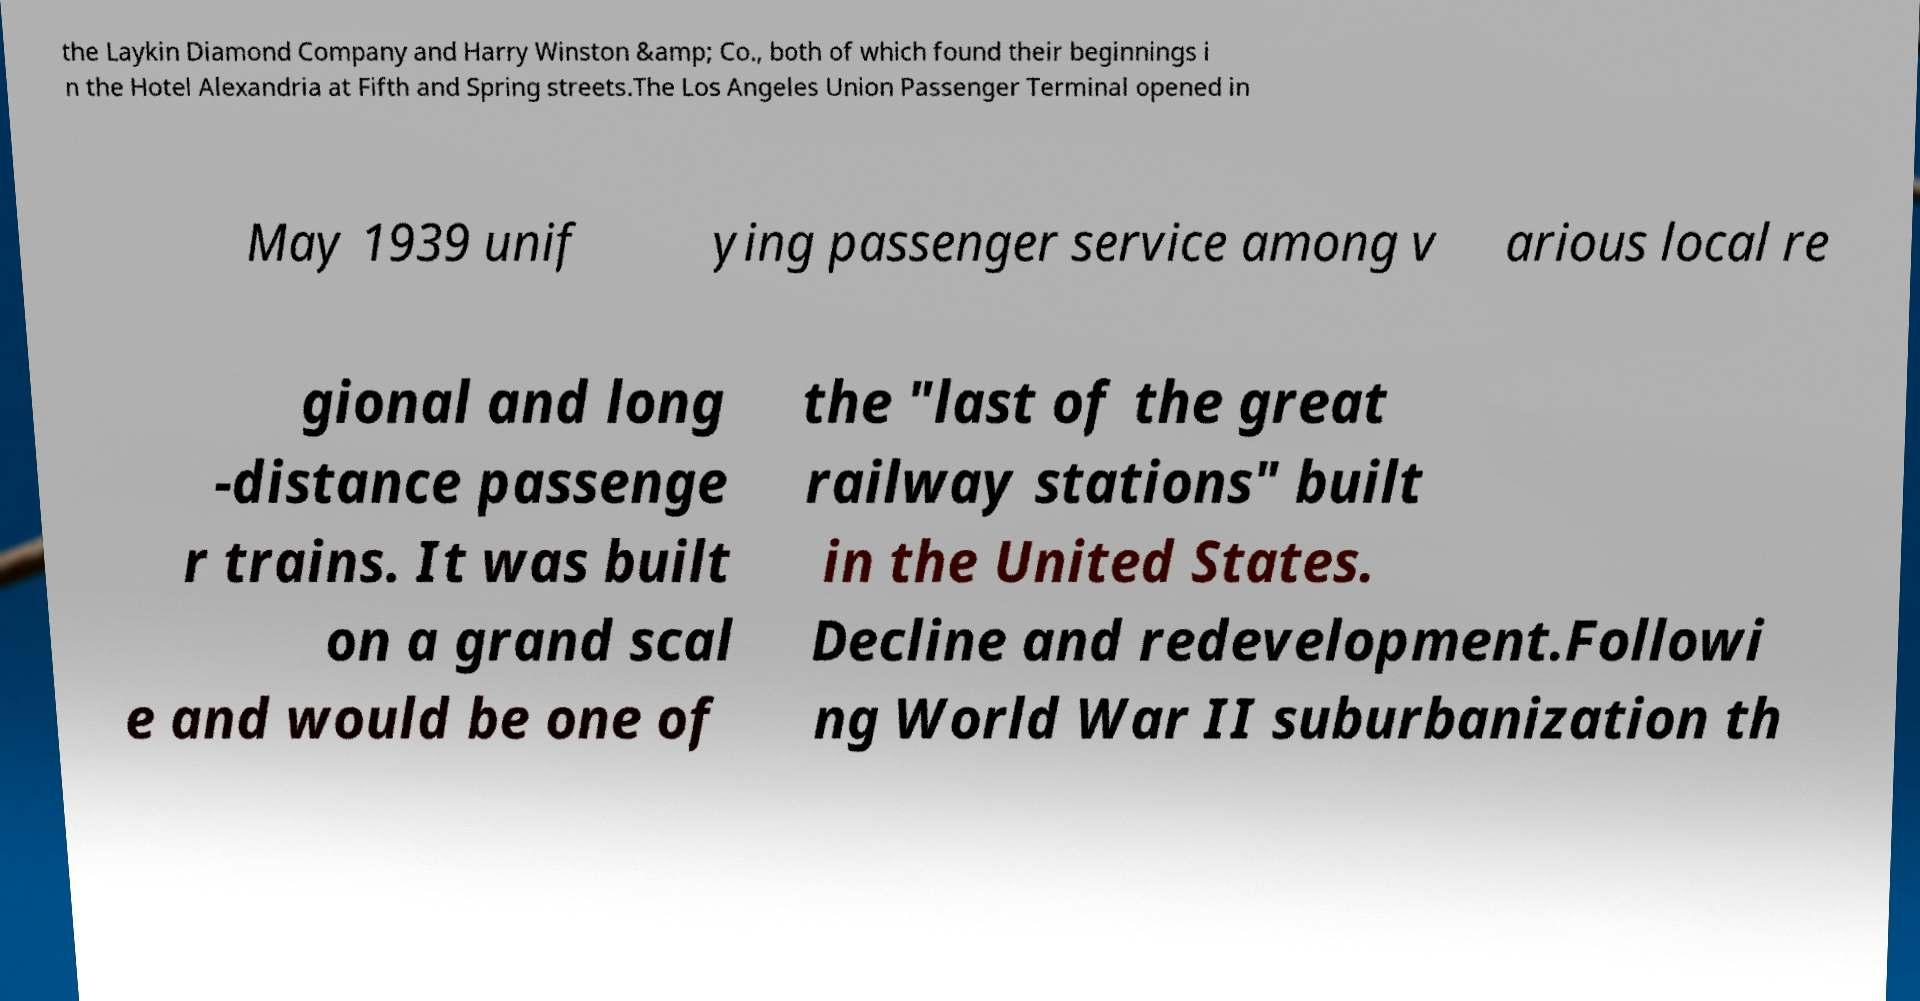Could you extract and type out the text from this image? the Laykin Diamond Company and Harry Winston &amp; Co., both of which found their beginnings i n the Hotel Alexandria at Fifth and Spring streets.The Los Angeles Union Passenger Terminal opened in May 1939 unif ying passenger service among v arious local re gional and long -distance passenge r trains. It was built on a grand scal e and would be one of the "last of the great railway stations" built in the United States. Decline and redevelopment.Followi ng World War II suburbanization th 